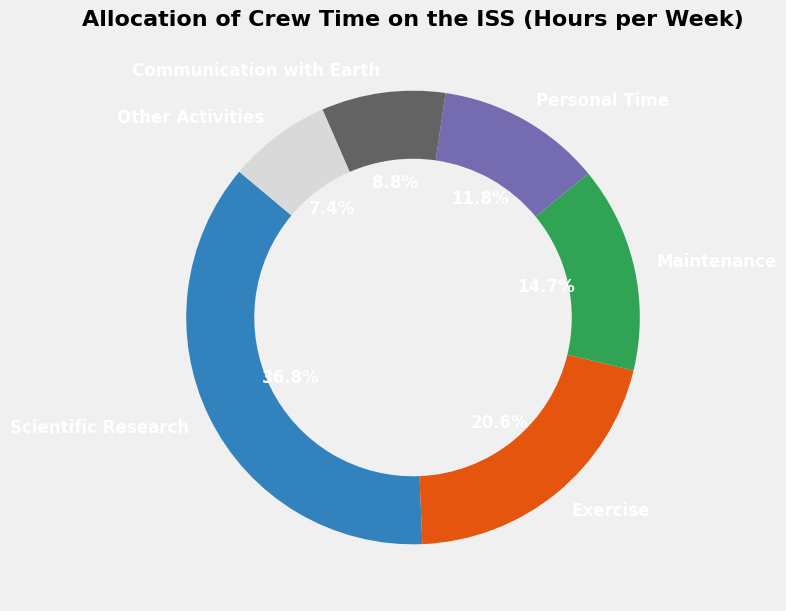Which activity consumes the most time per week? According to the pie chart, the largest wedge represents "Scientific Research" with 25 hours per week, indicating it consumes the most time.
Answer: Scientific Research How many more hours per week are spent on Scientific Research compared to Exercise? The pie chart shows that Scientific Research consumes 25 hours per week, while Exercise consumes 14 hours per week. The difference is 25 - 14.
Answer: 11 What percentage of the week is spent on Maintenance? The pie chart labels Maintenance as taking up 10 hours per week. Given that there are 168 hours in a week, the percentage is (10/168) * 100%.
Answer: 5.95% Is more time allocated to Communication with Earth than to Personal Time? The pie chart shows that 6 hours are allocated to Communication with Earth and 8 hours to Personal Time. Since 6 is less than 8, less time is spent on Communication with Earth.
Answer: No Calculate the combined hours spent on Maintenance and Other Activities. The pie chart shows Maintenance takes 10 hours and Other Activities take 5 hours per week. Adding them together, we get 10 + 5.
Answer: 15 What color represents Exercise in the pie chart? According to the pie chart, Exercise is assigned a specific color. By looking at the wedge labeled "Exercise," we can identify this color.
Answer: (Assumed color from visualization, e.g., blue) Which activity has the smallest allocation of time, and how many hours is it? The smallest wedge in the pie chart represents "Other Activities," which is labeled as taking up 5 hours per week.
Answer: Other Activities, 5 hours What is the percentage difference in time allocation between Scientific Research and Maintenance? Scientific Research is 25 hours and Maintenance is 10 hours. The percentage difference is ((25 - 10) / 10) * 100%.
Answer: 150% Does the crew spend more time on Personal Time or Communication with Earth? By how many hours? The pie chart indicates 8 hours for Personal Time and 6 hours for Communication with Earth. The difference is 8 - 6.
Answer: Personal Time, 2 hours 